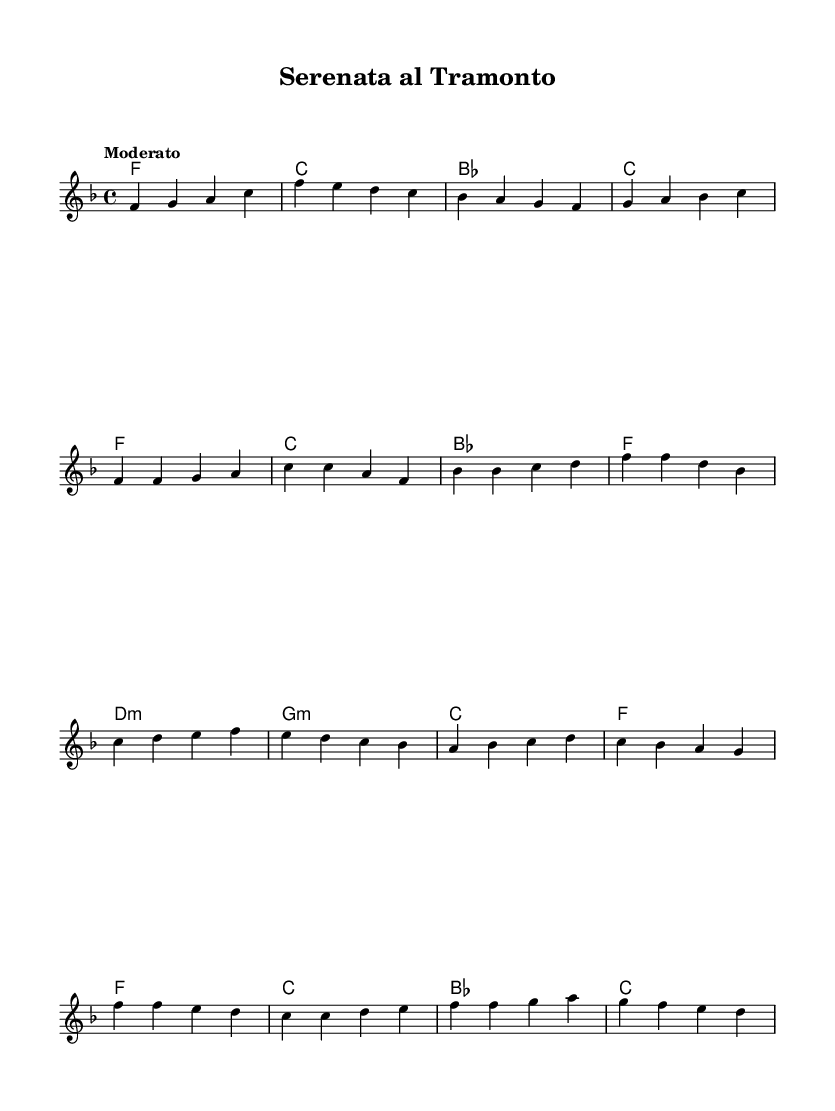What is the key signature of this music? The key signature is F major, which has one flat (B flat). This can be identified in the first measure of the score, where the flat sign is indicated.
Answer: F major What is the time signature of this music? The time signature is four-four, which can be seen at the beginning of the score. It indicates that there are four beats in each measure and the quarter note gets one beat.
Answer: Four-four What is the tempo marking of the piece? The tempo marking is "Moderato," which indicates a moderate pace. This is explicitly stated in the tempo section at the start of the score.
Answer: Moderato How many measures are in the chorus section? There are four measures in the chorus section. This can be determined by counting the number of measures listed under the chorus heading in the score.
Answer: Four What is the first chord of the pre-chorus? The first chord of the pre-chorus is D minor. This can be identified in the harmonies section where the chord is indicated on the first beat of the pre-chorus.
Answer: D minor Which musical form is primarily used in K-Pop, as reflected in this score? The musical form primarily used in K-Pop, as seen in this score, is verse-chorus form. In the provided music, the structure alternates between verses and choruses, a typical feature in K-Pop compositions.
Answer: Verse-chorus form What is the last note of the melody in the chorus? The last note of the melody in the chorus is D. This can be found by looking at the melody line in the chorus section and locating the final note in that specific part.
Answer: D 